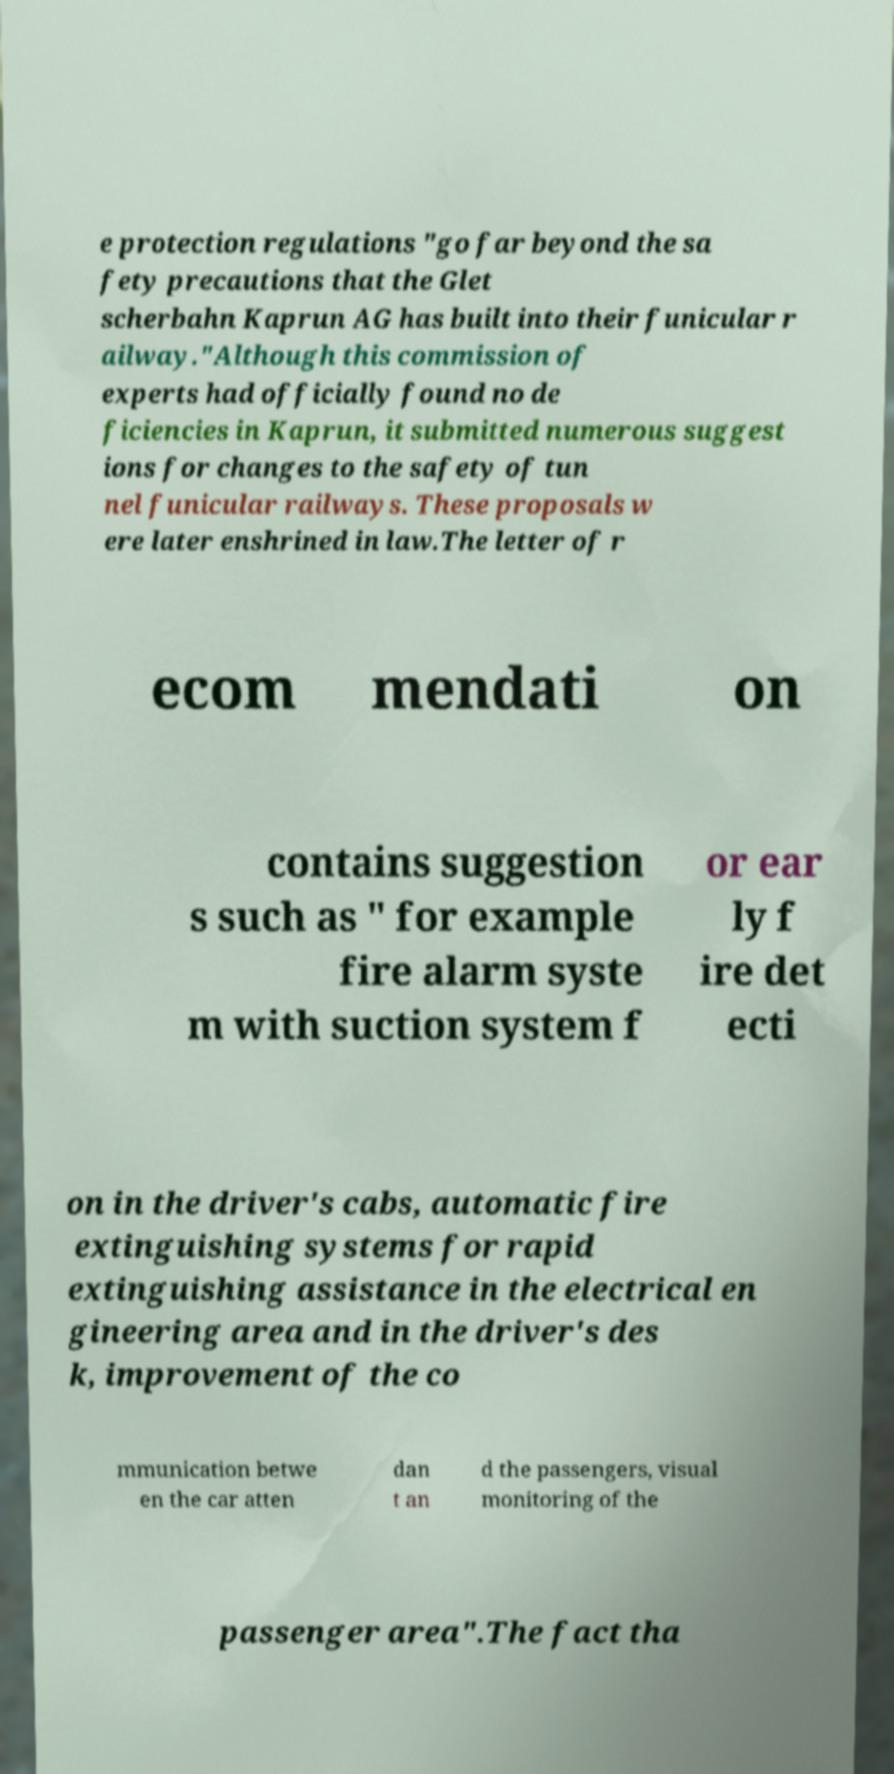Could you extract and type out the text from this image? e protection regulations "go far beyond the sa fety precautions that the Glet scherbahn Kaprun AG has built into their funicular r ailway."Although this commission of experts had officially found no de ficiencies in Kaprun, it submitted numerous suggest ions for changes to the safety of tun nel funicular railways. These proposals w ere later enshrined in law.The letter of r ecom mendati on contains suggestion s such as " for example fire alarm syste m with suction system f or ear ly f ire det ecti on in the driver's cabs, automatic fire extinguishing systems for rapid extinguishing assistance in the electrical en gineering area and in the driver's des k, improvement of the co mmunication betwe en the car atten dan t an d the passengers, visual monitoring of the passenger area".The fact tha 